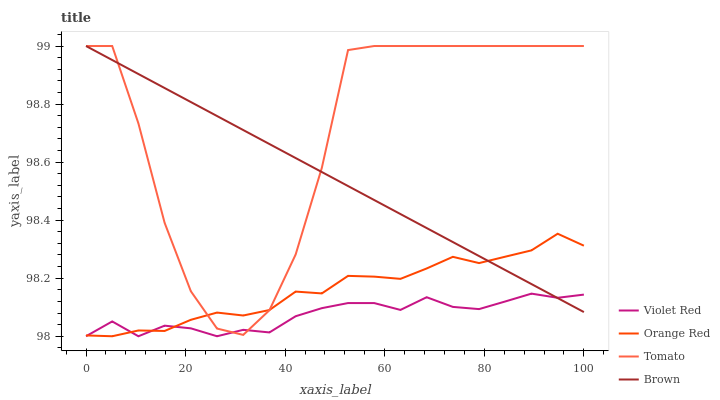Does Brown have the minimum area under the curve?
Answer yes or no. No. Does Brown have the maximum area under the curve?
Answer yes or no. No. Is Violet Red the smoothest?
Answer yes or no. No. Is Violet Red the roughest?
Answer yes or no. No. Does Brown have the lowest value?
Answer yes or no. No. Does Violet Red have the highest value?
Answer yes or no. No. 